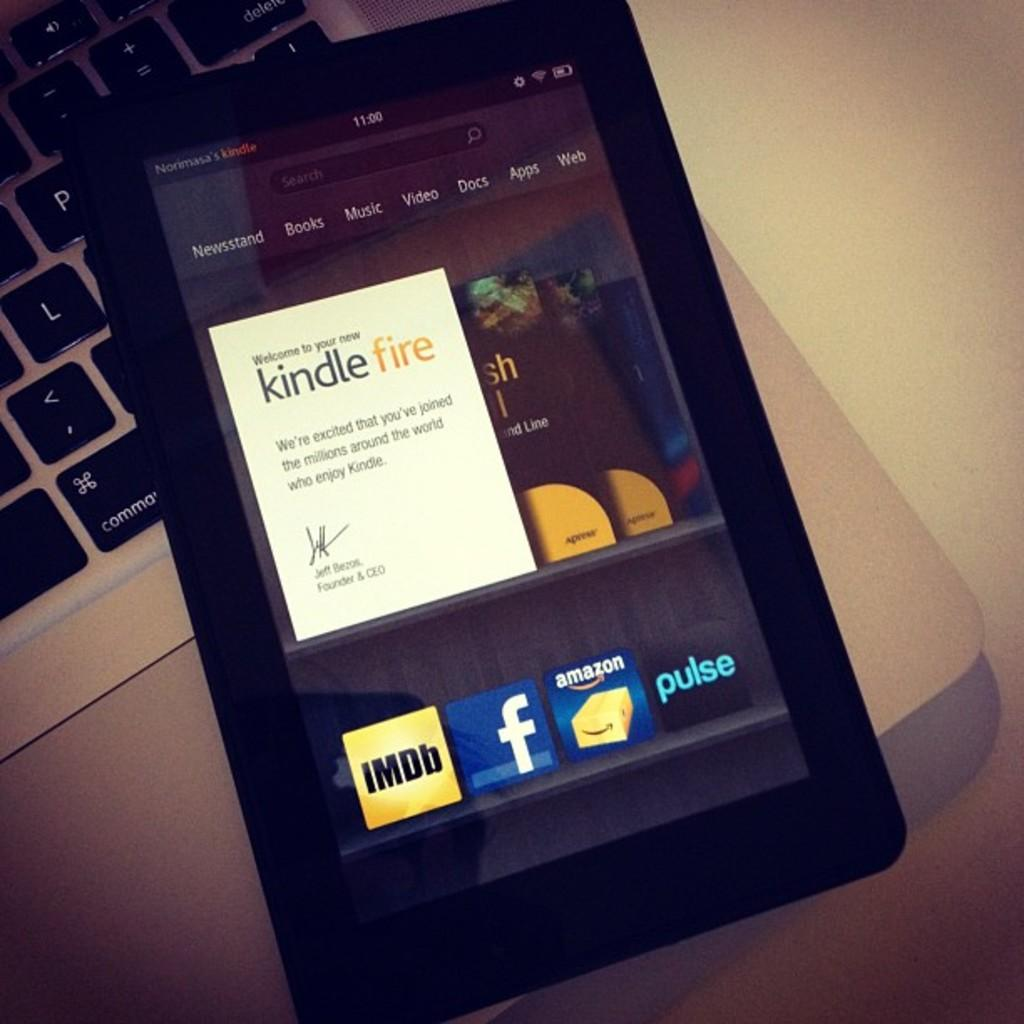What device is the mobile connected to in the image? The mobile is on a laptop in the image. What color is the surface that the laptop and mobile are on? The surface is white. Can you describe the position of the mobile on the laptop? The mobile is on the laptop, but the specific position cannot be determined from the image. What type of sweater is the baby wearing while sitting on the zephyr in the image? There is no baby, sweater, or zephyr present in the image. 